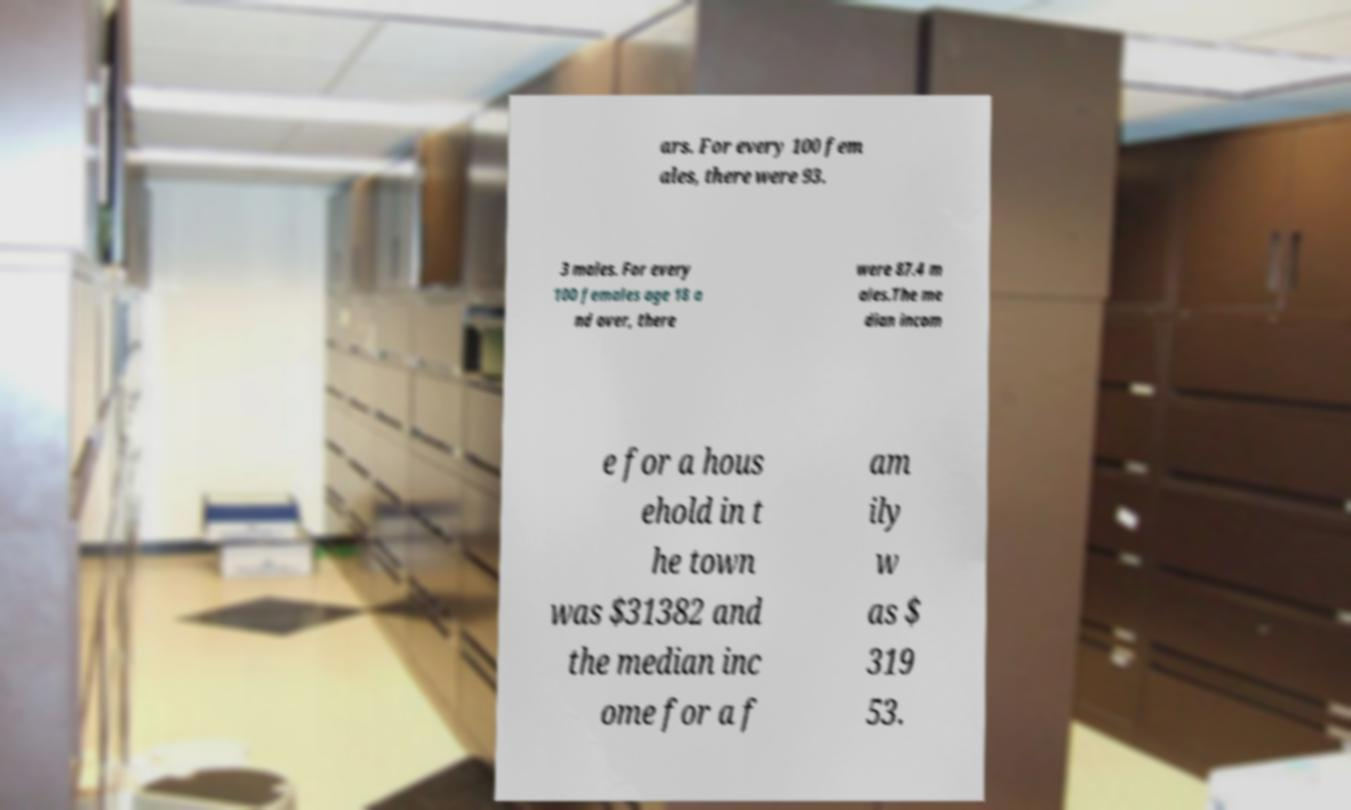Please read and relay the text visible in this image. What does it say? ars. For every 100 fem ales, there were 93. 3 males. For every 100 females age 18 a nd over, there were 87.4 m ales.The me dian incom e for a hous ehold in t he town was $31382 and the median inc ome for a f am ily w as $ 319 53. 